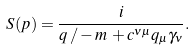Convert formula to latex. <formula><loc_0><loc_0><loc_500><loc_500>S ( p ) = \frac { i } { q \, / - m \, + c ^ { \nu \mu } q _ { \mu } \gamma _ { \nu } } .</formula> 